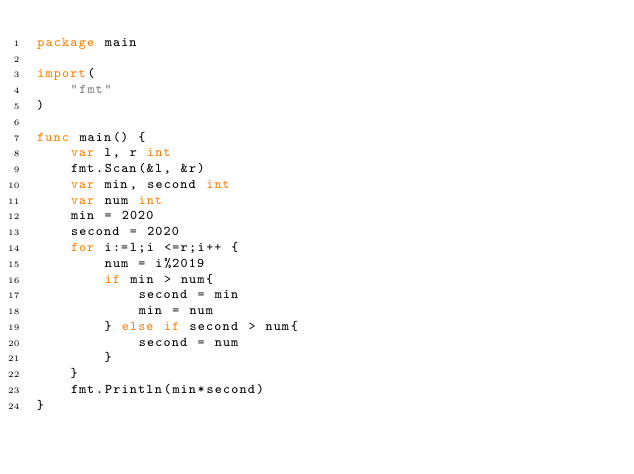Convert code to text. <code><loc_0><loc_0><loc_500><loc_500><_Go_>package main

import(
    "fmt"
)

func main() {
    var l, r int
    fmt.Scan(&l, &r)
    var min, second int
    var num int
    min = 2020
    second = 2020
    for i:=l;i <=r;i++ {
        num = i%2019
        if min > num{
            second = min
            min = num
        } else if second > num{
            second = num
        } 
    }
    fmt.Println(min*second)
}
</code> 